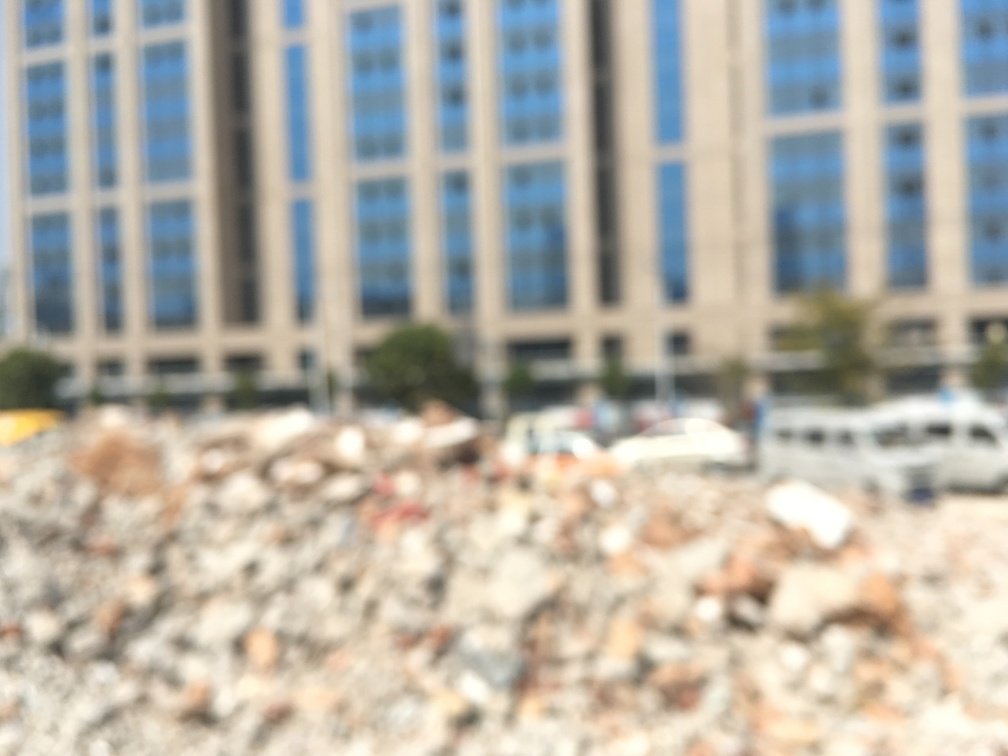What kind of area is shown in the image? Is it urban or rural, and can you describe the atmosphere or mood that the blurriness of the image might evoke? The area depicted in the image appears to be urban, given the presence of tall buildings and vehicles. However, because the image is blurred, it is impossible to ascertain specific details. The blurriness contributes to a sense of ambiguity and mystery. It might suggest a dynamic, bustling urban environment, where the pace of life leads to fleeting, blended impressions. Alternatively, it could evoke a sense of disorientation or confusion, potentially mirroring the feelings one might have when overwhelmed by urban stimuli. 